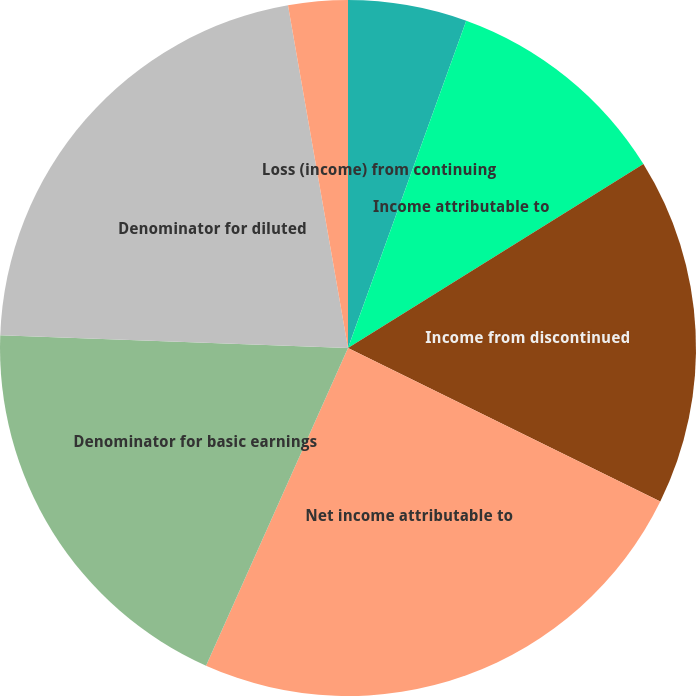Convert chart to OTSL. <chart><loc_0><loc_0><loc_500><loc_500><pie_chart><fcel>Loss (income) from continuing<fcel>Income attributable to<fcel>Income from discontinued<fcel>Net income attributable to<fcel>Denominator for basic earnings<fcel>Denominator for diluted<fcel>Loss from continuing<fcel>Net (loss) income attributable<nl><fcel>5.52%<fcel>10.62%<fcel>16.14%<fcel>24.42%<fcel>18.9%<fcel>21.66%<fcel>2.76%<fcel>0.0%<nl></chart> 